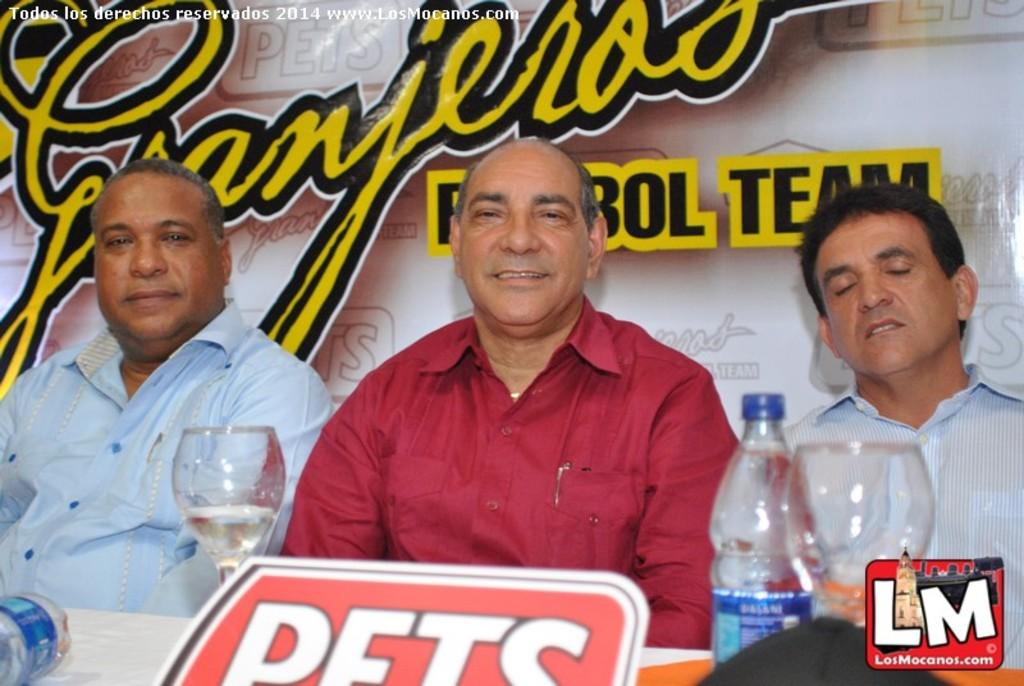<image>
Provide a brief description of the given image. Three men are sitting at a table and the icon in the lower right corner of the picture says LM on it. 